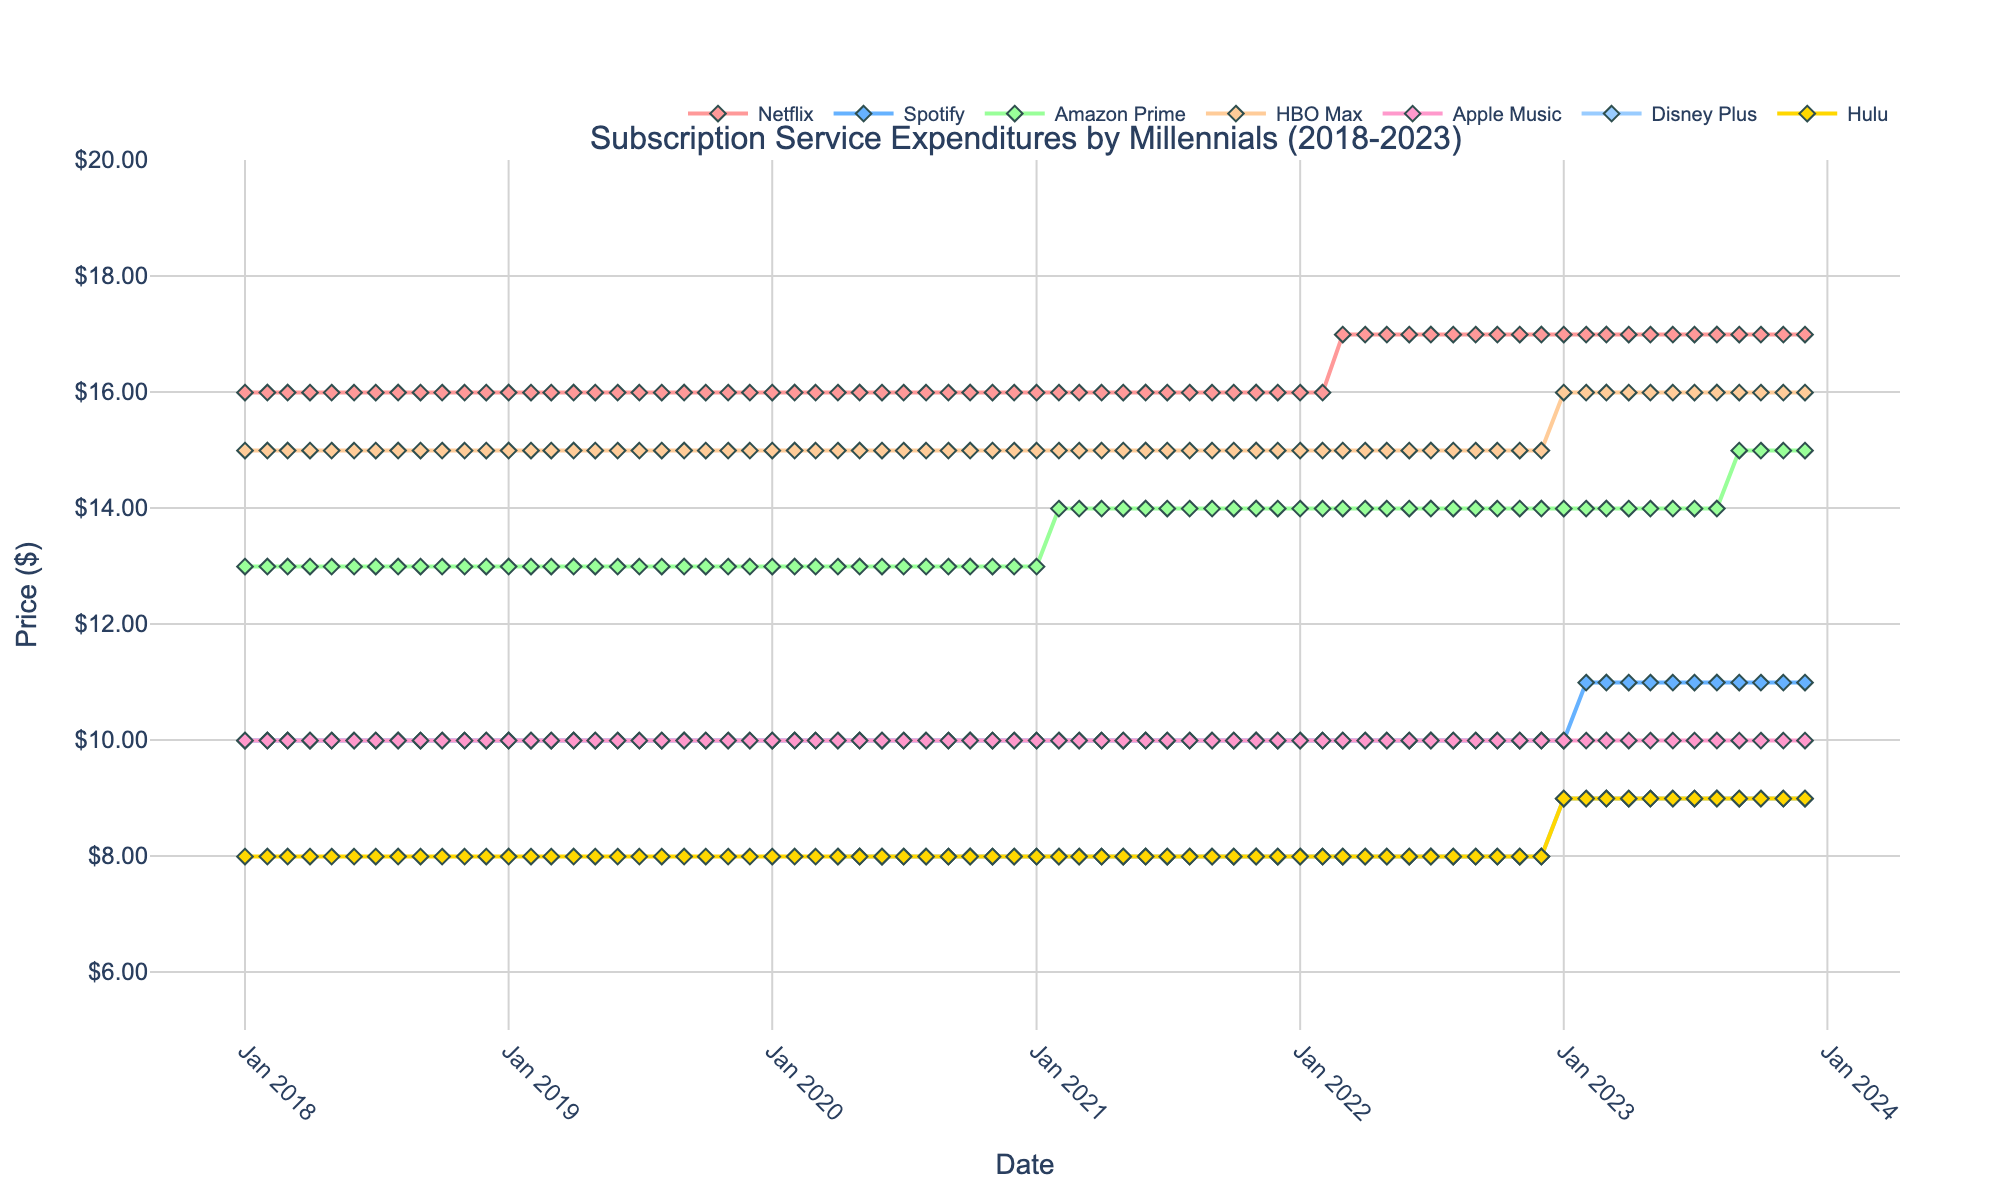What is the title of the figure? The title of the figure is located at the top and it states "Subscription Service Expenditures by Millennials (2018-2023)"
Answer: Subscription Service Expenditures by Millennials (2018-2023) Which subscription service showed the highest expenditure throughout the entire period? By observing the lines on the plot, the service with the highest consistent expenditure line is "Netflix", which never falls below $15.99 and reaches up to $16.99.
Answer: Netflix What was the price of Disney Plus in January 2020? Locate the point in January 2020 on the x-axis and follow the line for Disney Plus; the plot shows a data point at $7.99.
Answer: $7.99 When did Spotify first increase its price, and by how much? The first price increase for Spotify is in February 2023, where the price rises from $9.99 to $10.99, an increase of $1.
Answer: February 2023, $1 Did HBO Max experience any price changes from 2018 to 2023? Observing the HBO Max line, it remained constant at $14.99 until January 2023 when it increased to $15.99.
Answer: Yes, increased to $15.99 in January 2023 How many data points are there for each subscription service? The plot spans from January 2018 to December 2023, giving each service 72 monthly data points.
Answer: 72 Between January 2020 and January 2021, which new subscription services were added? By comparing the data points, both Disney Plus and Hulu start appearing in the data from April 2020 onwards.
Answer: Disney Plus and Hulu What is the average expenditure for Amazon Prime in 2019? The value for Amazon Prime in 2019 is consistently $12.99 each month. To find the average, the sum for 12 months is 12 x $12.99, which is $155.88. The average is $155.88/12 = $12.99.
Answer: $12.99 Which service had the steepest relative increase in price, and what was the amount? Spotify shows the steepest relative increase in February 2023, with a jump from $9.99 to $10.99, a relative increase of approximately 10.01%.
Answer: Spotify, 10.01% 